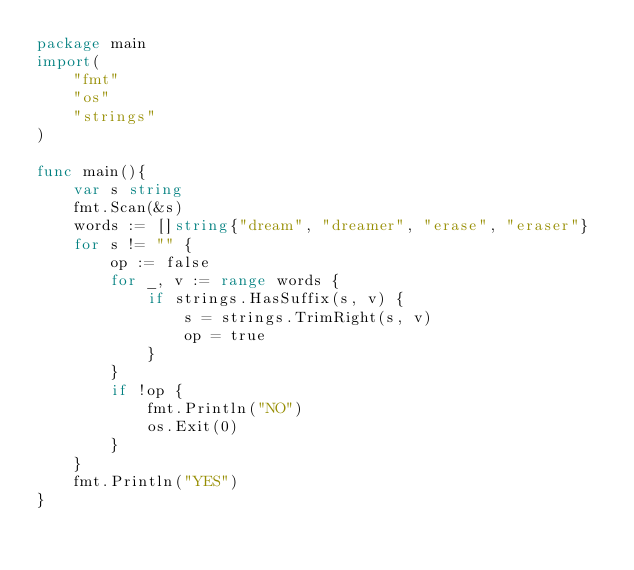<code> <loc_0><loc_0><loc_500><loc_500><_Go_>package main
import(
    "fmt"
    "os"
    "strings"
)

func main(){
    var s string
    fmt.Scan(&s)
    words := []string{"dream", "dreamer", "erase", "eraser"}
    for s != "" {
        op := false
        for _, v := range words {
            if strings.HasSuffix(s, v) {
                s = strings.TrimRight(s, v)
                op = true
            }
        }
        if !op {
            fmt.Println("NO")
            os.Exit(0)
        }
    }
    fmt.Println("YES")
}</code> 